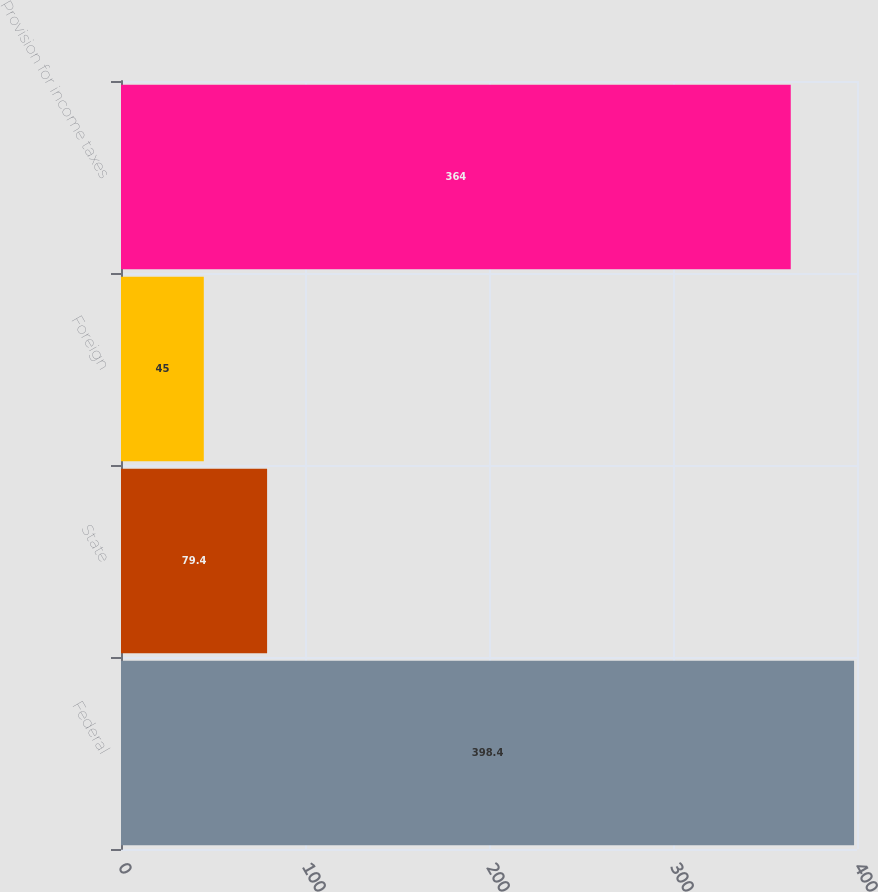<chart> <loc_0><loc_0><loc_500><loc_500><bar_chart><fcel>Federal<fcel>State<fcel>Foreign<fcel>Provision for income taxes<nl><fcel>398.4<fcel>79.4<fcel>45<fcel>364<nl></chart> 